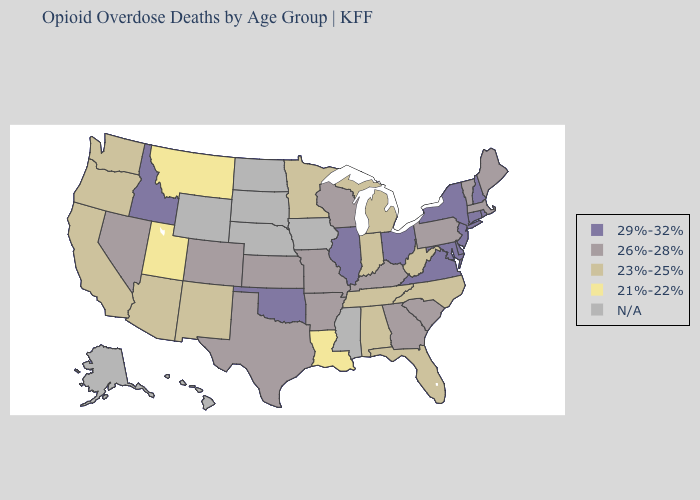What is the value of Tennessee?
Write a very short answer. 23%-25%. Name the states that have a value in the range 23%-25%?
Quick response, please. Alabama, Arizona, California, Florida, Indiana, Michigan, Minnesota, New Mexico, North Carolina, Oregon, Tennessee, Washington, West Virginia. What is the value of Alabama?
Keep it brief. 23%-25%. Does Kentucky have the lowest value in the South?
Give a very brief answer. No. Which states have the highest value in the USA?
Quick response, please. Connecticut, Delaware, Idaho, Illinois, Maryland, New Hampshire, New Jersey, New York, Ohio, Oklahoma, Rhode Island, Virginia. Name the states that have a value in the range 21%-22%?
Give a very brief answer. Louisiana, Montana, Utah. Does Maryland have the highest value in the USA?
Concise answer only. Yes. Name the states that have a value in the range 26%-28%?
Keep it brief. Arkansas, Colorado, Georgia, Kansas, Kentucky, Maine, Massachusetts, Missouri, Nevada, Pennsylvania, South Carolina, Texas, Vermont, Wisconsin. Name the states that have a value in the range 29%-32%?
Keep it brief. Connecticut, Delaware, Idaho, Illinois, Maryland, New Hampshire, New Jersey, New York, Ohio, Oklahoma, Rhode Island, Virginia. Does the first symbol in the legend represent the smallest category?
Be succinct. No. Does Utah have the lowest value in the USA?
Quick response, please. Yes. Name the states that have a value in the range 21%-22%?
Short answer required. Louisiana, Montana, Utah. What is the highest value in the USA?
Answer briefly. 29%-32%. What is the value of Maine?
Give a very brief answer. 26%-28%. Name the states that have a value in the range N/A?
Be succinct. Alaska, Hawaii, Iowa, Mississippi, Nebraska, North Dakota, South Dakota, Wyoming. 